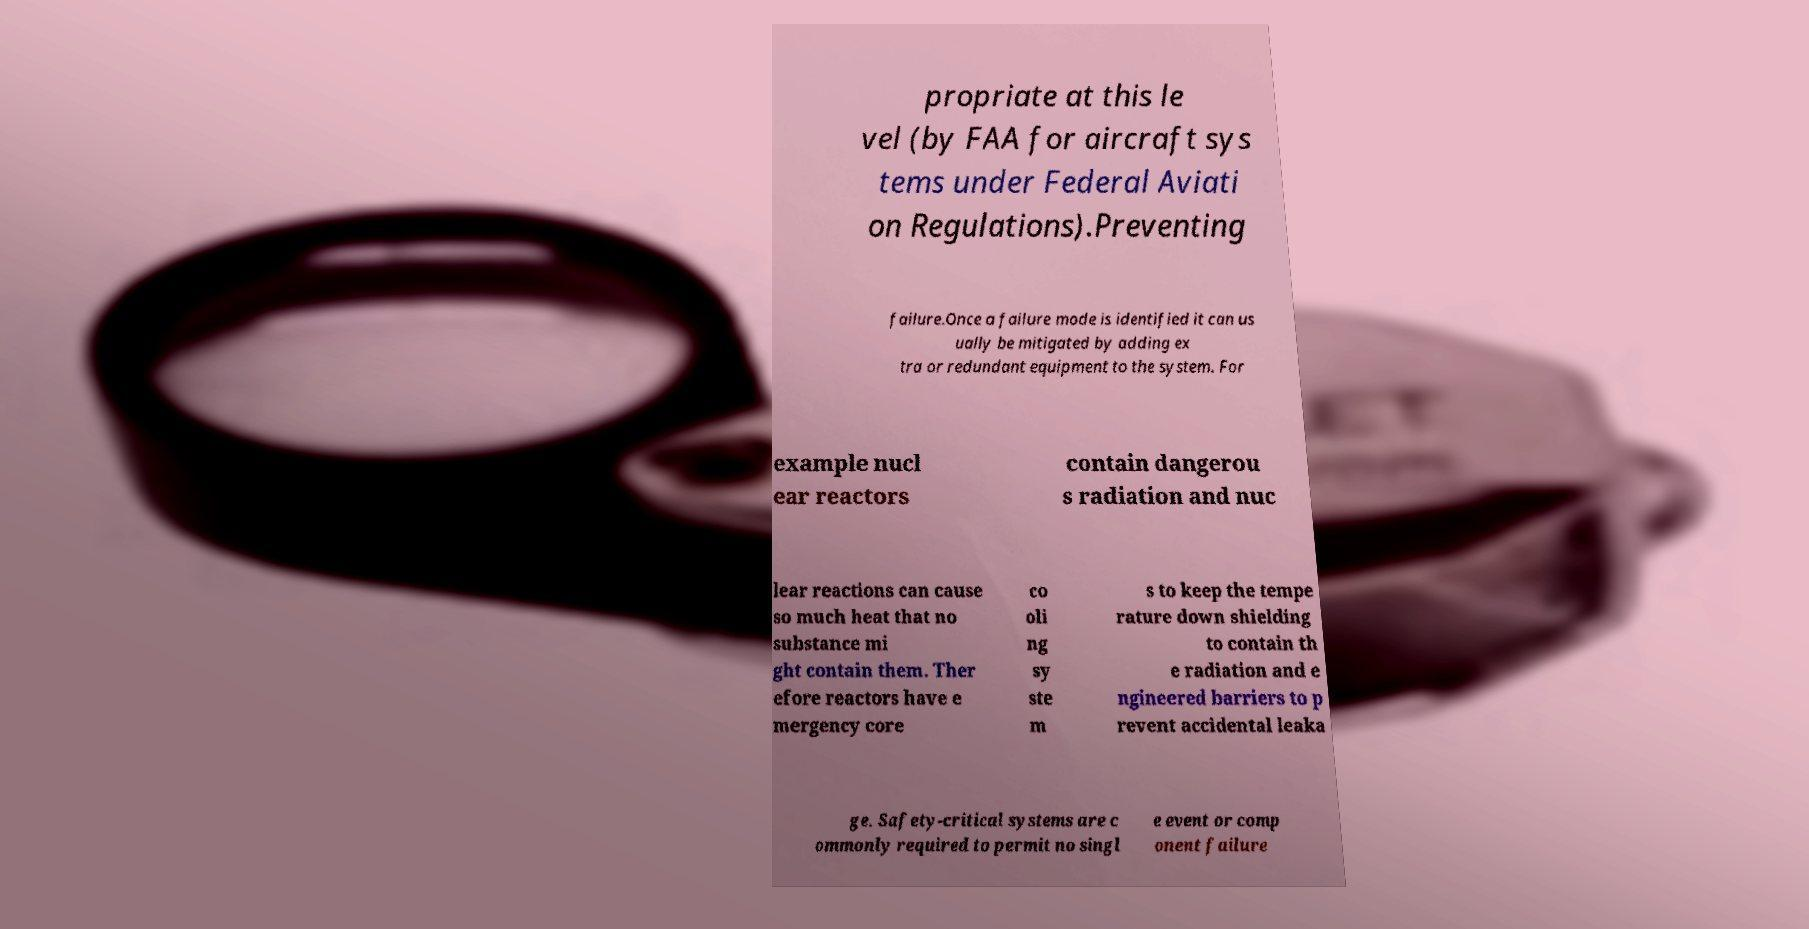For documentation purposes, I need the text within this image transcribed. Could you provide that? propriate at this le vel (by FAA for aircraft sys tems under Federal Aviati on Regulations).Preventing failure.Once a failure mode is identified it can us ually be mitigated by adding ex tra or redundant equipment to the system. For example nucl ear reactors contain dangerou s radiation and nuc lear reactions can cause so much heat that no substance mi ght contain them. Ther efore reactors have e mergency core co oli ng sy ste m s to keep the tempe rature down shielding to contain th e radiation and e ngineered barriers to p revent accidental leaka ge. Safety-critical systems are c ommonly required to permit no singl e event or comp onent failure 